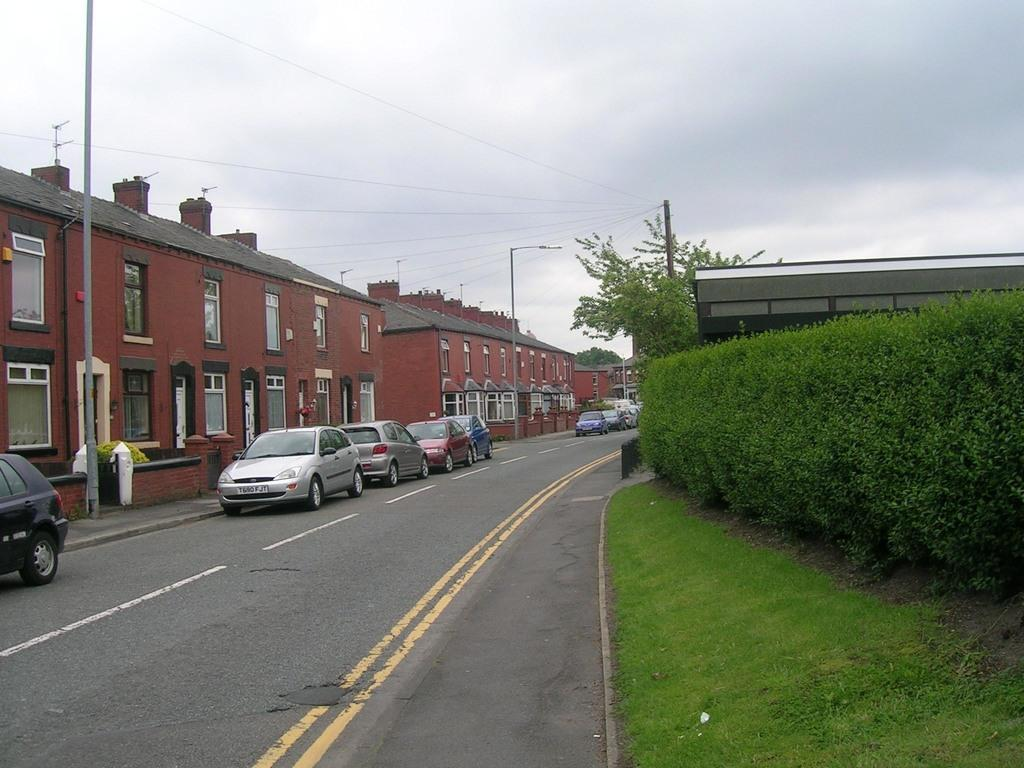What is the main subject in the middle of the image? There are cars and a road in the middle of the image. What type of natural environment is visible on the right side of the image? There are plants, trees, and grass on the right side of the image. What type of structures can be seen on the right side of the image? There is at least one building on the right side of the image. What type of man-made structures are visible on the left side of the image? There are buildings, street lights, and poles on the left side of the image. What part of the natural environment is visible on the left side of the image? The sky is visible on the left side of the image. What type of weather can be inferred from the image? Clouds are present in the sky, suggesting that it might be a partly cloudy day. What is the amusement park's income in the image? There is no amusement park present in the image, so it is not possible to determine its income. 